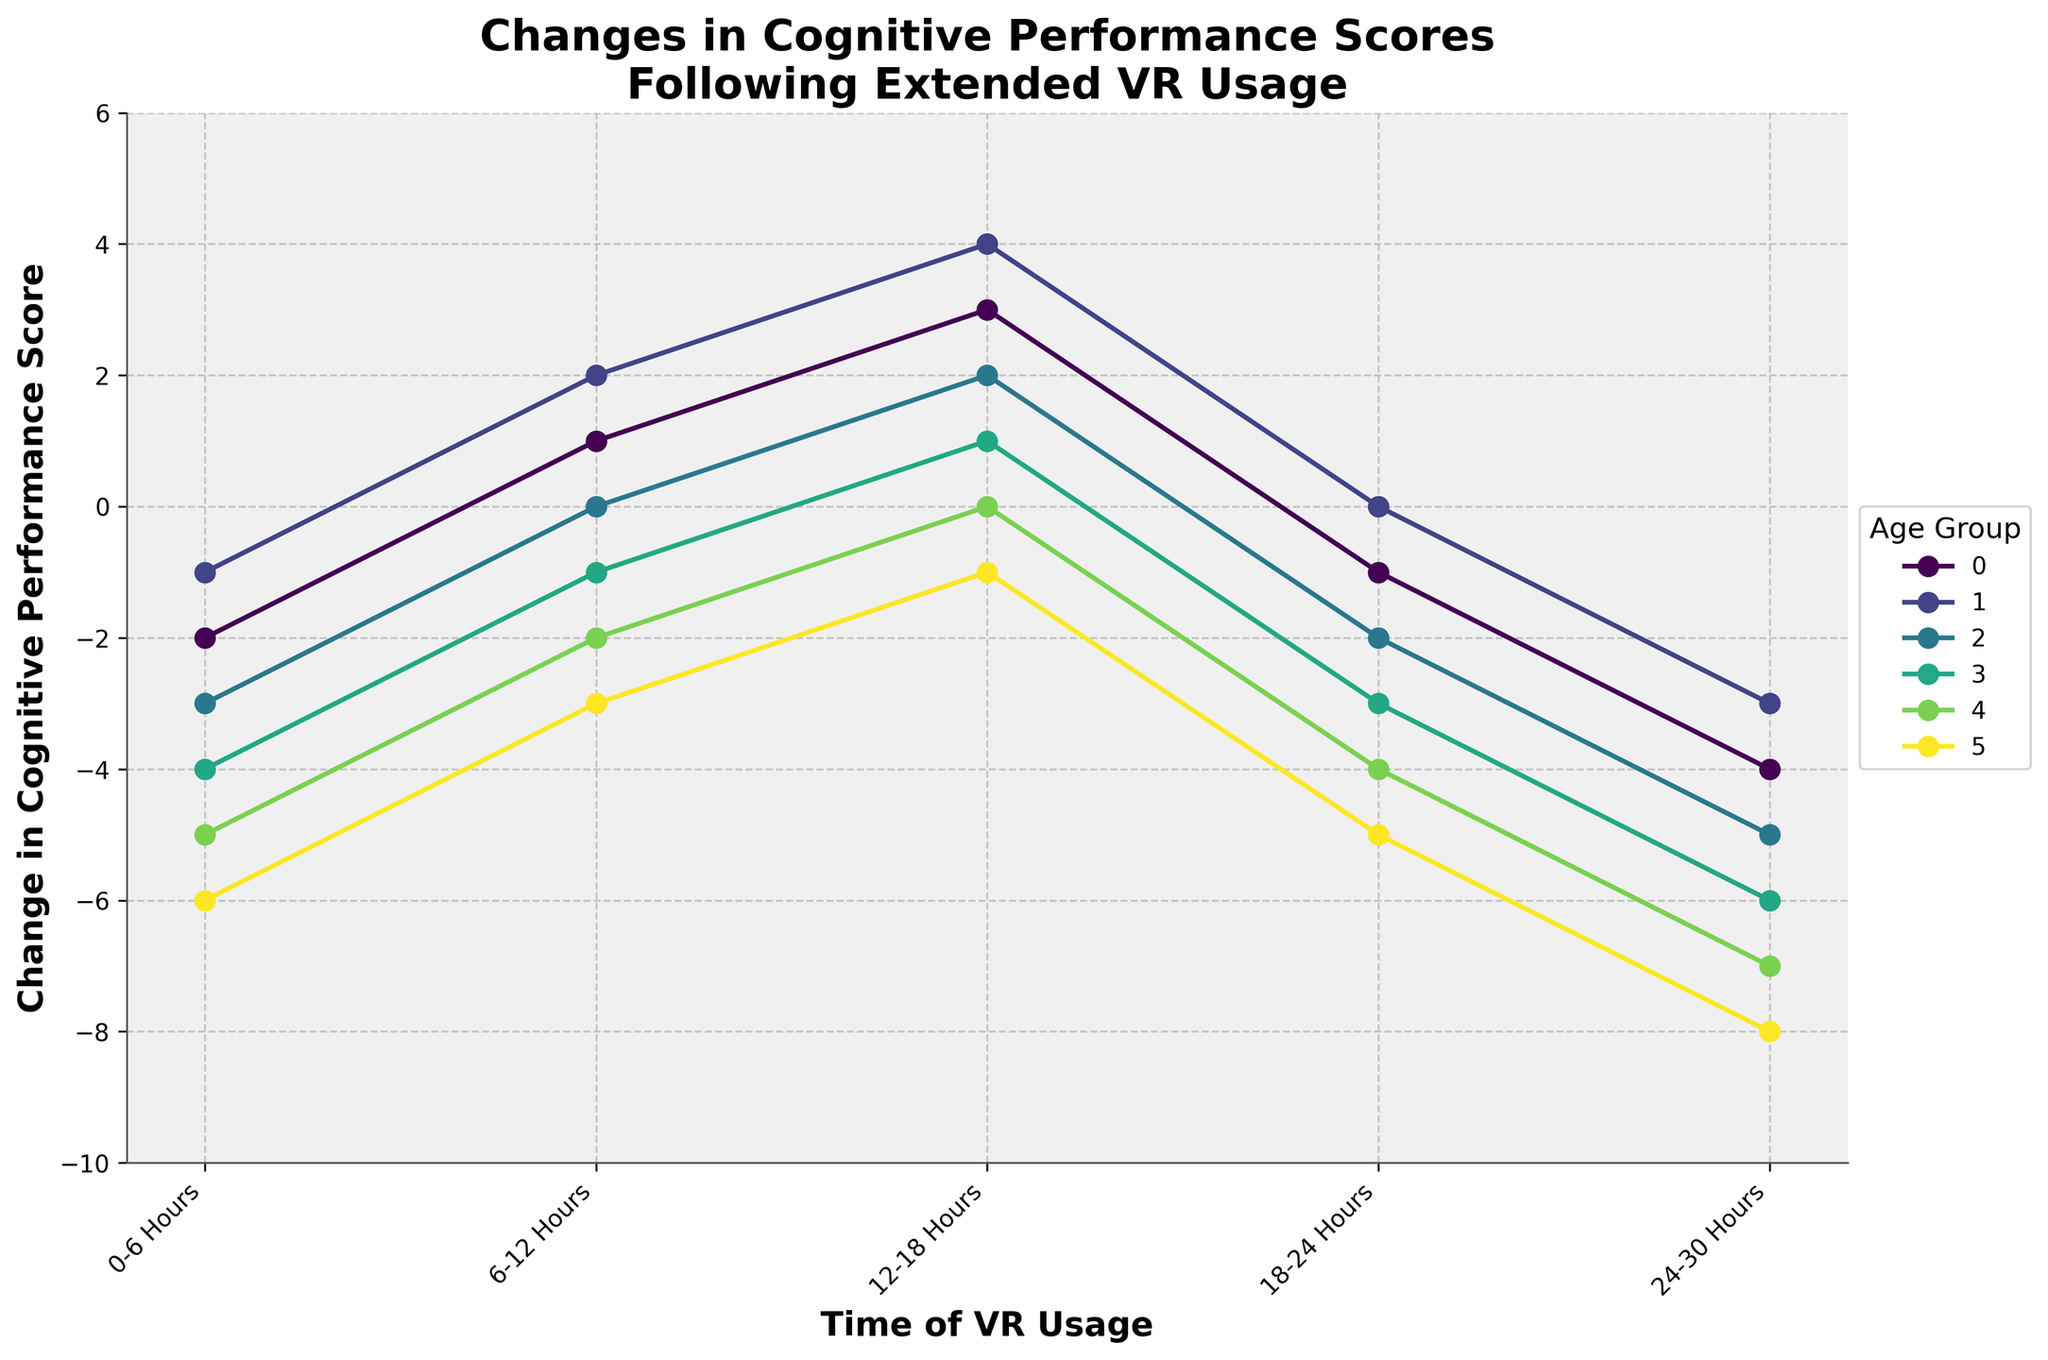What is the change in cognitive performance score for the age group 18-25 after 6-12 hours of VR usage? Locate the line labeled for the age group 18-25 and find the corresponding point for 6-12 hours. The score at this point is 1.
Answer: 1 Which age group shows the largest decline in cognitive performance score after 24-30 hours of VR usage? Compare the final data points (24-30 hours) for all age groups. The age group 65+ shows the largest decline with a score of -8.
Answer: 65+ Out of the age groups 36-45 and 46-55, which shows a greater improvement in score after 12-18 hours of VR usage and by how much? Find the scores for 12-18 hours of VR usage for both age groups (36-45 and 46-55). The scores are 2 and 1 respectively. The difference in improvement is 1 (2 - 1).
Answer: 36-45, by 1 At which time interval does the age group 26-35 reach its highest cognitive performance score, and what is the score? Look for the highest point in the line for age group 26-35. It reaches its highest after 12-18 hours with a score of 4.
Answer: 12-18 hours, 4 Compare the change in cognitive performance scores between the age groups 18-25 and 65+ after 0-6 hours of VR usage. Who has a better score and by how much? For the interval 0-6 hours, the score for age group 18-25 is -2 and for age group 65+ is -6. The difference is 4.
Answer: 18-25, by 4 How does the cognitive performance score trend for the age group 56-65 change over the intervals? For the age group 56-65, the scores over intervals are: -5, -2, 0, -4, -7. The trend shows an initial improvement up to 12-18 hours followed by a decline.
Answer: Initial improvement, then decline What is the average change in cognitive performance score for the age group 46-55 over all time intervals? The scores for the age group 46-55 are -4, -1, 1, -3, -6. Summing these scores gives -13. The average is -13 / 5 = -2.6.
Answer: -2.6 Which age group has the smallest decline in cognitive performance score after 12-18 hours of VR usage? Compare the values at the 12-18 hours mark for all age groups. The age group 26-35 has the highest score (4), indicating the smallest decline from a peak performance.
Answer: 26-35 What is the difference in cognitive performance scores for the age group 36-45 between 6-12 hours and 18-24 hours of VR usage? For the age group 36-45, the scores at 6-12 hours and 18-24 hours are 0 and -2 respectively. The difference is -2 - 0 = -2.
Answer: -2 How many age groups show an overall decline in cognitive performance score from 6-12 hours to 24-30 hours of VR usage? Check the trend in scores from 6-12 hours to 24-30 hours. All groups except 36-45 and 46-55 show an overall decline.
Answer: 4 